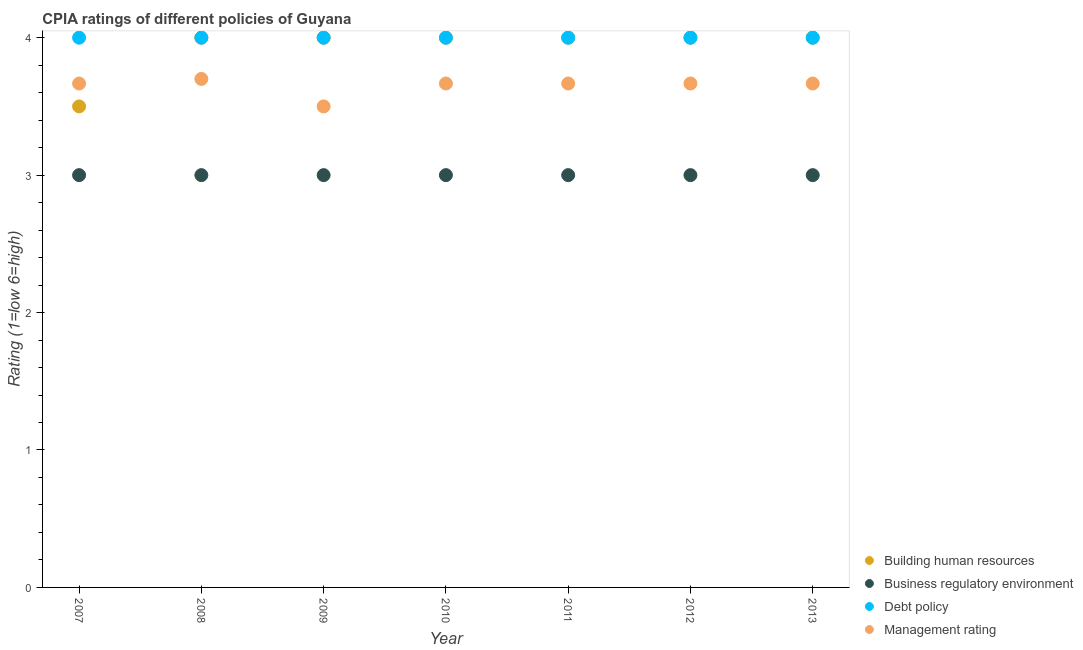How many different coloured dotlines are there?
Ensure brevity in your answer.  4. What is the cpia rating of business regulatory environment in 2009?
Ensure brevity in your answer.  3. Across all years, what is the minimum cpia rating of building human resources?
Keep it short and to the point. 3.5. In which year was the cpia rating of business regulatory environment maximum?
Your answer should be very brief. 2007. In which year was the cpia rating of management minimum?
Make the answer very short. 2009. What is the total cpia rating of management in the graph?
Your answer should be very brief. 25.53. What is the difference between the cpia rating of management in 2012 and the cpia rating of business regulatory environment in 2008?
Give a very brief answer. 0.67. What is the average cpia rating of management per year?
Provide a short and direct response. 3.65. In the year 2011, what is the difference between the cpia rating of building human resources and cpia rating of management?
Provide a succinct answer. 0.33. What is the ratio of the cpia rating of management in 2007 to that in 2008?
Keep it short and to the point. 0.99. Is the cpia rating of building human resources in 2008 less than that in 2012?
Offer a terse response. No. In how many years, is the cpia rating of building human resources greater than the average cpia rating of building human resources taken over all years?
Provide a succinct answer. 6. Is it the case that in every year, the sum of the cpia rating of management and cpia rating of business regulatory environment is greater than the sum of cpia rating of building human resources and cpia rating of debt policy?
Ensure brevity in your answer.  No. Does the cpia rating of management monotonically increase over the years?
Offer a terse response. No. Is the cpia rating of business regulatory environment strictly greater than the cpia rating of management over the years?
Ensure brevity in your answer.  No. How many dotlines are there?
Provide a short and direct response. 4. How many years are there in the graph?
Offer a terse response. 7. Does the graph contain any zero values?
Your answer should be very brief. No. Does the graph contain grids?
Your response must be concise. No. How are the legend labels stacked?
Your answer should be compact. Vertical. What is the title of the graph?
Offer a very short reply. CPIA ratings of different policies of Guyana. What is the label or title of the X-axis?
Give a very brief answer. Year. What is the Rating (1=low 6=high) in Debt policy in 2007?
Your response must be concise. 4. What is the Rating (1=low 6=high) of Management rating in 2007?
Your answer should be very brief. 3.67. What is the Rating (1=low 6=high) of Debt policy in 2008?
Provide a succinct answer. 4. What is the Rating (1=low 6=high) in Management rating in 2008?
Your answer should be compact. 3.7. What is the Rating (1=low 6=high) of Business regulatory environment in 2009?
Offer a very short reply. 3. What is the Rating (1=low 6=high) in Debt policy in 2009?
Provide a short and direct response. 4. What is the Rating (1=low 6=high) of Management rating in 2009?
Ensure brevity in your answer.  3.5. What is the Rating (1=low 6=high) in Business regulatory environment in 2010?
Make the answer very short. 3. What is the Rating (1=low 6=high) in Debt policy in 2010?
Give a very brief answer. 4. What is the Rating (1=low 6=high) of Management rating in 2010?
Provide a succinct answer. 3.67. What is the Rating (1=low 6=high) of Building human resources in 2011?
Offer a very short reply. 4. What is the Rating (1=low 6=high) in Business regulatory environment in 2011?
Offer a terse response. 3. What is the Rating (1=low 6=high) of Debt policy in 2011?
Ensure brevity in your answer.  4. What is the Rating (1=low 6=high) in Management rating in 2011?
Give a very brief answer. 3.67. What is the Rating (1=low 6=high) of Building human resources in 2012?
Offer a very short reply. 4. What is the Rating (1=low 6=high) of Business regulatory environment in 2012?
Offer a terse response. 3. What is the Rating (1=low 6=high) of Management rating in 2012?
Make the answer very short. 3.67. What is the Rating (1=low 6=high) in Building human resources in 2013?
Make the answer very short. 4. What is the Rating (1=low 6=high) of Management rating in 2013?
Your answer should be compact. 3.67. Across all years, what is the maximum Rating (1=low 6=high) of Building human resources?
Your answer should be compact. 4. Across all years, what is the maximum Rating (1=low 6=high) in Business regulatory environment?
Your answer should be compact. 3. Across all years, what is the maximum Rating (1=low 6=high) in Debt policy?
Make the answer very short. 4. Across all years, what is the minimum Rating (1=low 6=high) of Building human resources?
Ensure brevity in your answer.  3.5. What is the total Rating (1=low 6=high) in Business regulatory environment in the graph?
Provide a short and direct response. 21. What is the total Rating (1=low 6=high) in Debt policy in the graph?
Offer a very short reply. 28. What is the total Rating (1=low 6=high) in Management rating in the graph?
Give a very brief answer. 25.53. What is the difference between the Rating (1=low 6=high) in Business regulatory environment in 2007 and that in 2008?
Make the answer very short. 0. What is the difference between the Rating (1=low 6=high) in Debt policy in 2007 and that in 2008?
Your answer should be very brief. 0. What is the difference between the Rating (1=low 6=high) in Management rating in 2007 and that in 2008?
Your answer should be very brief. -0.03. What is the difference between the Rating (1=low 6=high) in Building human resources in 2007 and that in 2009?
Provide a short and direct response. -0.5. What is the difference between the Rating (1=low 6=high) in Building human resources in 2007 and that in 2010?
Provide a short and direct response. -0.5. What is the difference between the Rating (1=low 6=high) of Business regulatory environment in 2007 and that in 2010?
Provide a short and direct response. 0. What is the difference between the Rating (1=low 6=high) of Building human resources in 2007 and that in 2011?
Your answer should be compact. -0.5. What is the difference between the Rating (1=low 6=high) of Business regulatory environment in 2007 and that in 2011?
Ensure brevity in your answer.  0. What is the difference between the Rating (1=low 6=high) in Debt policy in 2007 and that in 2011?
Your response must be concise. 0. What is the difference between the Rating (1=low 6=high) of Debt policy in 2007 and that in 2012?
Your answer should be compact. 0. What is the difference between the Rating (1=low 6=high) in Building human resources in 2007 and that in 2013?
Provide a succinct answer. -0.5. What is the difference between the Rating (1=low 6=high) of Debt policy in 2007 and that in 2013?
Offer a terse response. 0. What is the difference between the Rating (1=low 6=high) in Management rating in 2007 and that in 2013?
Offer a terse response. 0. What is the difference between the Rating (1=low 6=high) of Building human resources in 2008 and that in 2009?
Give a very brief answer. 0. What is the difference between the Rating (1=low 6=high) of Business regulatory environment in 2008 and that in 2009?
Keep it short and to the point. 0. What is the difference between the Rating (1=low 6=high) in Management rating in 2008 and that in 2009?
Keep it short and to the point. 0.2. What is the difference between the Rating (1=low 6=high) of Business regulatory environment in 2008 and that in 2010?
Make the answer very short. 0. What is the difference between the Rating (1=low 6=high) of Building human resources in 2008 and that in 2011?
Provide a succinct answer. 0. What is the difference between the Rating (1=low 6=high) of Debt policy in 2008 and that in 2012?
Your response must be concise. 0. What is the difference between the Rating (1=low 6=high) in Management rating in 2008 and that in 2012?
Provide a succinct answer. 0.03. What is the difference between the Rating (1=low 6=high) of Debt policy in 2008 and that in 2013?
Give a very brief answer. 0. What is the difference between the Rating (1=low 6=high) of Management rating in 2008 and that in 2013?
Provide a short and direct response. 0.03. What is the difference between the Rating (1=low 6=high) of Building human resources in 2009 and that in 2010?
Provide a short and direct response. 0. What is the difference between the Rating (1=low 6=high) of Building human resources in 2009 and that in 2011?
Your answer should be very brief. 0. What is the difference between the Rating (1=low 6=high) in Debt policy in 2009 and that in 2011?
Your answer should be compact. 0. What is the difference between the Rating (1=low 6=high) of Management rating in 2009 and that in 2011?
Your answer should be very brief. -0.17. What is the difference between the Rating (1=low 6=high) of Building human resources in 2009 and that in 2012?
Make the answer very short. 0. What is the difference between the Rating (1=low 6=high) in Business regulatory environment in 2009 and that in 2012?
Provide a succinct answer. 0. What is the difference between the Rating (1=low 6=high) of Debt policy in 2009 and that in 2012?
Make the answer very short. 0. What is the difference between the Rating (1=low 6=high) of Debt policy in 2009 and that in 2013?
Provide a short and direct response. 0. What is the difference between the Rating (1=low 6=high) of Building human resources in 2010 and that in 2011?
Offer a very short reply. 0. What is the difference between the Rating (1=low 6=high) in Management rating in 2010 and that in 2011?
Offer a very short reply. 0. What is the difference between the Rating (1=low 6=high) in Building human resources in 2010 and that in 2012?
Offer a terse response. 0. What is the difference between the Rating (1=low 6=high) in Business regulatory environment in 2010 and that in 2012?
Your answer should be very brief. 0. What is the difference between the Rating (1=low 6=high) in Debt policy in 2010 and that in 2012?
Give a very brief answer. 0. What is the difference between the Rating (1=low 6=high) of Management rating in 2010 and that in 2012?
Give a very brief answer. 0. What is the difference between the Rating (1=low 6=high) in Business regulatory environment in 2011 and that in 2013?
Your answer should be very brief. 0. What is the difference between the Rating (1=low 6=high) in Debt policy in 2011 and that in 2013?
Make the answer very short. 0. What is the difference between the Rating (1=low 6=high) in Management rating in 2011 and that in 2013?
Offer a very short reply. 0. What is the difference between the Rating (1=low 6=high) of Business regulatory environment in 2012 and that in 2013?
Offer a very short reply. 0. What is the difference between the Rating (1=low 6=high) of Debt policy in 2012 and that in 2013?
Give a very brief answer. 0. What is the difference between the Rating (1=low 6=high) of Management rating in 2012 and that in 2013?
Give a very brief answer. 0. What is the difference between the Rating (1=low 6=high) in Building human resources in 2007 and the Rating (1=low 6=high) in Debt policy in 2008?
Offer a very short reply. -0.5. What is the difference between the Rating (1=low 6=high) in Business regulatory environment in 2007 and the Rating (1=low 6=high) in Debt policy in 2008?
Provide a short and direct response. -1. What is the difference between the Rating (1=low 6=high) in Debt policy in 2007 and the Rating (1=low 6=high) in Management rating in 2008?
Offer a very short reply. 0.3. What is the difference between the Rating (1=low 6=high) of Building human resources in 2007 and the Rating (1=low 6=high) of Debt policy in 2009?
Your answer should be compact. -0.5. What is the difference between the Rating (1=low 6=high) in Business regulatory environment in 2007 and the Rating (1=low 6=high) in Management rating in 2009?
Your answer should be compact. -0.5. What is the difference between the Rating (1=low 6=high) in Building human resources in 2007 and the Rating (1=low 6=high) in Business regulatory environment in 2010?
Keep it short and to the point. 0.5. What is the difference between the Rating (1=low 6=high) of Business regulatory environment in 2007 and the Rating (1=low 6=high) of Debt policy in 2010?
Provide a succinct answer. -1. What is the difference between the Rating (1=low 6=high) of Debt policy in 2007 and the Rating (1=low 6=high) of Management rating in 2010?
Provide a succinct answer. 0.33. What is the difference between the Rating (1=low 6=high) of Building human resources in 2007 and the Rating (1=low 6=high) of Debt policy in 2011?
Offer a very short reply. -0.5. What is the difference between the Rating (1=low 6=high) in Building human resources in 2007 and the Rating (1=low 6=high) in Management rating in 2011?
Offer a terse response. -0.17. What is the difference between the Rating (1=low 6=high) of Business regulatory environment in 2007 and the Rating (1=low 6=high) of Debt policy in 2011?
Ensure brevity in your answer.  -1. What is the difference between the Rating (1=low 6=high) in Debt policy in 2007 and the Rating (1=low 6=high) in Management rating in 2011?
Your response must be concise. 0.33. What is the difference between the Rating (1=low 6=high) in Building human resources in 2007 and the Rating (1=low 6=high) in Business regulatory environment in 2012?
Provide a short and direct response. 0.5. What is the difference between the Rating (1=low 6=high) in Business regulatory environment in 2007 and the Rating (1=low 6=high) in Debt policy in 2012?
Offer a terse response. -1. What is the difference between the Rating (1=low 6=high) in Debt policy in 2007 and the Rating (1=low 6=high) in Management rating in 2012?
Provide a short and direct response. 0.33. What is the difference between the Rating (1=low 6=high) in Building human resources in 2007 and the Rating (1=low 6=high) in Debt policy in 2013?
Make the answer very short. -0.5. What is the difference between the Rating (1=low 6=high) of Building human resources in 2007 and the Rating (1=low 6=high) of Management rating in 2013?
Make the answer very short. -0.17. What is the difference between the Rating (1=low 6=high) in Business regulatory environment in 2007 and the Rating (1=low 6=high) in Debt policy in 2013?
Keep it short and to the point. -1. What is the difference between the Rating (1=low 6=high) in Debt policy in 2007 and the Rating (1=low 6=high) in Management rating in 2013?
Give a very brief answer. 0.33. What is the difference between the Rating (1=low 6=high) in Building human resources in 2008 and the Rating (1=low 6=high) in Debt policy in 2009?
Keep it short and to the point. 0. What is the difference between the Rating (1=low 6=high) of Business regulatory environment in 2008 and the Rating (1=low 6=high) of Debt policy in 2009?
Offer a terse response. -1. What is the difference between the Rating (1=low 6=high) of Business regulatory environment in 2008 and the Rating (1=low 6=high) of Management rating in 2009?
Give a very brief answer. -0.5. What is the difference between the Rating (1=low 6=high) in Debt policy in 2008 and the Rating (1=low 6=high) in Management rating in 2009?
Keep it short and to the point. 0.5. What is the difference between the Rating (1=low 6=high) in Business regulatory environment in 2008 and the Rating (1=low 6=high) in Management rating in 2010?
Ensure brevity in your answer.  -0.67. What is the difference between the Rating (1=low 6=high) of Building human resources in 2008 and the Rating (1=low 6=high) of Debt policy in 2011?
Provide a short and direct response. 0. What is the difference between the Rating (1=low 6=high) of Building human resources in 2008 and the Rating (1=low 6=high) of Management rating in 2011?
Keep it short and to the point. 0.33. What is the difference between the Rating (1=low 6=high) of Business regulatory environment in 2008 and the Rating (1=low 6=high) of Debt policy in 2011?
Give a very brief answer. -1. What is the difference between the Rating (1=low 6=high) in Debt policy in 2008 and the Rating (1=low 6=high) in Management rating in 2011?
Provide a short and direct response. 0.33. What is the difference between the Rating (1=low 6=high) of Building human resources in 2008 and the Rating (1=low 6=high) of Business regulatory environment in 2012?
Provide a short and direct response. 1. What is the difference between the Rating (1=low 6=high) of Building human resources in 2008 and the Rating (1=low 6=high) of Debt policy in 2012?
Your answer should be compact. 0. What is the difference between the Rating (1=low 6=high) of Business regulatory environment in 2008 and the Rating (1=low 6=high) of Debt policy in 2012?
Keep it short and to the point. -1. What is the difference between the Rating (1=low 6=high) of Building human resources in 2008 and the Rating (1=low 6=high) of Business regulatory environment in 2013?
Provide a succinct answer. 1. What is the difference between the Rating (1=low 6=high) of Building human resources in 2009 and the Rating (1=low 6=high) of Management rating in 2010?
Your response must be concise. 0.33. What is the difference between the Rating (1=low 6=high) of Debt policy in 2009 and the Rating (1=low 6=high) of Management rating in 2010?
Provide a succinct answer. 0.33. What is the difference between the Rating (1=low 6=high) of Building human resources in 2009 and the Rating (1=low 6=high) of Business regulatory environment in 2011?
Your response must be concise. 1. What is the difference between the Rating (1=low 6=high) in Business regulatory environment in 2009 and the Rating (1=low 6=high) in Debt policy in 2011?
Keep it short and to the point. -1. What is the difference between the Rating (1=low 6=high) in Building human resources in 2009 and the Rating (1=low 6=high) in Debt policy in 2012?
Give a very brief answer. 0. What is the difference between the Rating (1=low 6=high) in Business regulatory environment in 2009 and the Rating (1=low 6=high) in Debt policy in 2012?
Ensure brevity in your answer.  -1. What is the difference between the Rating (1=low 6=high) of Business regulatory environment in 2009 and the Rating (1=low 6=high) of Management rating in 2012?
Your answer should be compact. -0.67. What is the difference between the Rating (1=low 6=high) in Debt policy in 2009 and the Rating (1=low 6=high) in Management rating in 2012?
Make the answer very short. 0.33. What is the difference between the Rating (1=low 6=high) in Building human resources in 2009 and the Rating (1=low 6=high) in Business regulatory environment in 2013?
Your answer should be very brief. 1. What is the difference between the Rating (1=low 6=high) of Building human resources in 2009 and the Rating (1=low 6=high) of Management rating in 2013?
Provide a short and direct response. 0.33. What is the difference between the Rating (1=low 6=high) in Business regulatory environment in 2009 and the Rating (1=low 6=high) in Debt policy in 2013?
Offer a terse response. -1. What is the difference between the Rating (1=low 6=high) in Business regulatory environment in 2009 and the Rating (1=low 6=high) in Management rating in 2013?
Give a very brief answer. -0.67. What is the difference between the Rating (1=low 6=high) of Business regulatory environment in 2010 and the Rating (1=low 6=high) of Debt policy in 2011?
Ensure brevity in your answer.  -1. What is the difference between the Rating (1=low 6=high) of Business regulatory environment in 2010 and the Rating (1=low 6=high) of Management rating in 2011?
Give a very brief answer. -0.67. What is the difference between the Rating (1=low 6=high) in Business regulatory environment in 2010 and the Rating (1=low 6=high) in Debt policy in 2012?
Keep it short and to the point. -1. What is the difference between the Rating (1=low 6=high) of Debt policy in 2010 and the Rating (1=low 6=high) of Management rating in 2012?
Offer a very short reply. 0.33. What is the difference between the Rating (1=low 6=high) in Building human resources in 2010 and the Rating (1=low 6=high) in Debt policy in 2013?
Offer a very short reply. 0. What is the difference between the Rating (1=low 6=high) of Building human resources in 2010 and the Rating (1=low 6=high) of Management rating in 2013?
Give a very brief answer. 0.33. What is the difference between the Rating (1=low 6=high) in Business regulatory environment in 2010 and the Rating (1=low 6=high) in Debt policy in 2013?
Offer a terse response. -1. What is the difference between the Rating (1=low 6=high) in Building human resources in 2011 and the Rating (1=low 6=high) in Business regulatory environment in 2012?
Your response must be concise. 1. What is the difference between the Rating (1=low 6=high) in Building human resources in 2011 and the Rating (1=low 6=high) in Debt policy in 2012?
Your answer should be compact. 0. What is the difference between the Rating (1=low 6=high) of Building human resources in 2011 and the Rating (1=low 6=high) of Management rating in 2012?
Offer a very short reply. 0.33. What is the difference between the Rating (1=low 6=high) of Business regulatory environment in 2011 and the Rating (1=low 6=high) of Debt policy in 2012?
Your response must be concise. -1. What is the difference between the Rating (1=low 6=high) of Business regulatory environment in 2011 and the Rating (1=low 6=high) of Management rating in 2012?
Make the answer very short. -0.67. What is the difference between the Rating (1=low 6=high) of Debt policy in 2011 and the Rating (1=low 6=high) of Management rating in 2012?
Your response must be concise. 0.33. What is the difference between the Rating (1=low 6=high) in Building human resources in 2011 and the Rating (1=low 6=high) in Management rating in 2013?
Provide a succinct answer. 0.33. What is the difference between the Rating (1=low 6=high) of Business regulatory environment in 2011 and the Rating (1=low 6=high) of Debt policy in 2013?
Keep it short and to the point. -1. What is the difference between the Rating (1=low 6=high) in Business regulatory environment in 2011 and the Rating (1=low 6=high) in Management rating in 2013?
Your answer should be compact. -0.67. What is the difference between the Rating (1=low 6=high) in Building human resources in 2012 and the Rating (1=low 6=high) in Debt policy in 2013?
Make the answer very short. 0. What is the difference between the Rating (1=low 6=high) in Building human resources in 2012 and the Rating (1=low 6=high) in Management rating in 2013?
Give a very brief answer. 0.33. What is the difference between the Rating (1=low 6=high) of Business regulatory environment in 2012 and the Rating (1=low 6=high) of Debt policy in 2013?
Offer a very short reply. -1. What is the difference between the Rating (1=low 6=high) of Business regulatory environment in 2012 and the Rating (1=low 6=high) of Management rating in 2013?
Offer a very short reply. -0.67. What is the difference between the Rating (1=low 6=high) of Debt policy in 2012 and the Rating (1=low 6=high) of Management rating in 2013?
Provide a succinct answer. 0.33. What is the average Rating (1=low 6=high) in Building human resources per year?
Give a very brief answer. 3.93. What is the average Rating (1=low 6=high) in Management rating per year?
Your response must be concise. 3.65. In the year 2007, what is the difference between the Rating (1=low 6=high) of Building human resources and Rating (1=low 6=high) of Business regulatory environment?
Ensure brevity in your answer.  0.5. In the year 2007, what is the difference between the Rating (1=low 6=high) in Business regulatory environment and Rating (1=low 6=high) in Management rating?
Your answer should be compact. -0.67. In the year 2009, what is the difference between the Rating (1=low 6=high) in Building human resources and Rating (1=low 6=high) in Management rating?
Your answer should be compact. 0.5. In the year 2009, what is the difference between the Rating (1=low 6=high) in Business regulatory environment and Rating (1=low 6=high) in Debt policy?
Your answer should be compact. -1. In the year 2009, what is the difference between the Rating (1=low 6=high) of Debt policy and Rating (1=low 6=high) of Management rating?
Keep it short and to the point. 0.5. In the year 2010, what is the difference between the Rating (1=low 6=high) of Building human resources and Rating (1=low 6=high) of Business regulatory environment?
Your answer should be very brief. 1. In the year 2010, what is the difference between the Rating (1=low 6=high) in Building human resources and Rating (1=low 6=high) in Debt policy?
Keep it short and to the point. 0. In the year 2010, what is the difference between the Rating (1=low 6=high) of Building human resources and Rating (1=low 6=high) of Management rating?
Your response must be concise. 0.33. In the year 2010, what is the difference between the Rating (1=low 6=high) of Business regulatory environment and Rating (1=low 6=high) of Debt policy?
Provide a short and direct response. -1. In the year 2010, what is the difference between the Rating (1=low 6=high) of Business regulatory environment and Rating (1=low 6=high) of Management rating?
Offer a very short reply. -0.67. In the year 2010, what is the difference between the Rating (1=low 6=high) in Debt policy and Rating (1=low 6=high) in Management rating?
Give a very brief answer. 0.33. In the year 2011, what is the difference between the Rating (1=low 6=high) in Building human resources and Rating (1=low 6=high) in Management rating?
Keep it short and to the point. 0.33. In the year 2011, what is the difference between the Rating (1=low 6=high) in Debt policy and Rating (1=low 6=high) in Management rating?
Give a very brief answer. 0.33. In the year 2012, what is the difference between the Rating (1=low 6=high) in Building human resources and Rating (1=low 6=high) in Business regulatory environment?
Offer a very short reply. 1. In the year 2012, what is the difference between the Rating (1=low 6=high) of Building human resources and Rating (1=low 6=high) of Management rating?
Ensure brevity in your answer.  0.33. In the year 2012, what is the difference between the Rating (1=low 6=high) of Debt policy and Rating (1=low 6=high) of Management rating?
Provide a succinct answer. 0.33. In the year 2013, what is the difference between the Rating (1=low 6=high) in Building human resources and Rating (1=low 6=high) in Debt policy?
Offer a terse response. 0. In the year 2013, what is the difference between the Rating (1=low 6=high) in Building human resources and Rating (1=low 6=high) in Management rating?
Your response must be concise. 0.33. What is the ratio of the Rating (1=low 6=high) in Building human resources in 2007 to that in 2008?
Offer a terse response. 0.88. What is the ratio of the Rating (1=low 6=high) of Business regulatory environment in 2007 to that in 2008?
Your answer should be compact. 1. What is the ratio of the Rating (1=low 6=high) in Debt policy in 2007 to that in 2008?
Your response must be concise. 1. What is the ratio of the Rating (1=low 6=high) of Building human resources in 2007 to that in 2009?
Keep it short and to the point. 0.88. What is the ratio of the Rating (1=low 6=high) of Debt policy in 2007 to that in 2009?
Your response must be concise. 1. What is the ratio of the Rating (1=low 6=high) in Management rating in 2007 to that in 2009?
Provide a succinct answer. 1.05. What is the ratio of the Rating (1=low 6=high) in Business regulatory environment in 2007 to that in 2010?
Keep it short and to the point. 1. What is the ratio of the Rating (1=low 6=high) of Management rating in 2007 to that in 2010?
Offer a terse response. 1. What is the ratio of the Rating (1=low 6=high) in Building human resources in 2007 to that in 2011?
Ensure brevity in your answer.  0.88. What is the ratio of the Rating (1=low 6=high) in Business regulatory environment in 2007 to that in 2011?
Your answer should be very brief. 1. What is the ratio of the Rating (1=low 6=high) in Building human resources in 2007 to that in 2012?
Keep it short and to the point. 0.88. What is the ratio of the Rating (1=low 6=high) in Business regulatory environment in 2007 to that in 2012?
Provide a succinct answer. 1. What is the ratio of the Rating (1=low 6=high) in Building human resources in 2007 to that in 2013?
Offer a very short reply. 0.88. What is the ratio of the Rating (1=low 6=high) in Business regulatory environment in 2007 to that in 2013?
Your response must be concise. 1. What is the ratio of the Rating (1=low 6=high) of Management rating in 2007 to that in 2013?
Your answer should be very brief. 1. What is the ratio of the Rating (1=low 6=high) of Building human resources in 2008 to that in 2009?
Your response must be concise. 1. What is the ratio of the Rating (1=low 6=high) in Debt policy in 2008 to that in 2009?
Offer a terse response. 1. What is the ratio of the Rating (1=low 6=high) in Management rating in 2008 to that in 2009?
Your response must be concise. 1.06. What is the ratio of the Rating (1=low 6=high) of Building human resources in 2008 to that in 2010?
Your answer should be very brief. 1. What is the ratio of the Rating (1=low 6=high) of Business regulatory environment in 2008 to that in 2010?
Keep it short and to the point. 1. What is the ratio of the Rating (1=low 6=high) of Management rating in 2008 to that in 2010?
Make the answer very short. 1.01. What is the ratio of the Rating (1=low 6=high) of Building human resources in 2008 to that in 2011?
Your answer should be very brief. 1. What is the ratio of the Rating (1=low 6=high) of Business regulatory environment in 2008 to that in 2011?
Your answer should be very brief. 1. What is the ratio of the Rating (1=low 6=high) of Debt policy in 2008 to that in 2011?
Your answer should be very brief. 1. What is the ratio of the Rating (1=low 6=high) of Management rating in 2008 to that in 2011?
Your response must be concise. 1.01. What is the ratio of the Rating (1=low 6=high) in Building human resources in 2008 to that in 2012?
Your response must be concise. 1. What is the ratio of the Rating (1=low 6=high) in Business regulatory environment in 2008 to that in 2012?
Ensure brevity in your answer.  1. What is the ratio of the Rating (1=low 6=high) in Debt policy in 2008 to that in 2012?
Ensure brevity in your answer.  1. What is the ratio of the Rating (1=low 6=high) of Management rating in 2008 to that in 2012?
Your answer should be compact. 1.01. What is the ratio of the Rating (1=low 6=high) of Debt policy in 2008 to that in 2013?
Your answer should be very brief. 1. What is the ratio of the Rating (1=low 6=high) of Management rating in 2008 to that in 2013?
Give a very brief answer. 1.01. What is the ratio of the Rating (1=low 6=high) in Debt policy in 2009 to that in 2010?
Provide a short and direct response. 1. What is the ratio of the Rating (1=low 6=high) of Management rating in 2009 to that in 2010?
Your answer should be compact. 0.95. What is the ratio of the Rating (1=low 6=high) in Management rating in 2009 to that in 2011?
Ensure brevity in your answer.  0.95. What is the ratio of the Rating (1=low 6=high) in Building human resources in 2009 to that in 2012?
Your answer should be compact. 1. What is the ratio of the Rating (1=low 6=high) of Business regulatory environment in 2009 to that in 2012?
Provide a succinct answer. 1. What is the ratio of the Rating (1=low 6=high) in Management rating in 2009 to that in 2012?
Make the answer very short. 0.95. What is the ratio of the Rating (1=low 6=high) of Building human resources in 2009 to that in 2013?
Provide a succinct answer. 1. What is the ratio of the Rating (1=low 6=high) of Management rating in 2009 to that in 2013?
Make the answer very short. 0.95. What is the ratio of the Rating (1=low 6=high) in Building human resources in 2010 to that in 2011?
Provide a succinct answer. 1. What is the ratio of the Rating (1=low 6=high) in Business regulatory environment in 2010 to that in 2011?
Your response must be concise. 1. What is the ratio of the Rating (1=low 6=high) in Building human resources in 2010 to that in 2012?
Give a very brief answer. 1. What is the ratio of the Rating (1=low 6=high) of Business regulatory environment in 2010 to that in 2012?
Offer a terse response. 1. What is the ratio of the Rating (1=low 6=high) of Debt policy in 2010 to that in 2012?
Your answer should be compact. 1. What is the ratio of the Rating (1=low 6=high) in Management rating in 2010 to that in 2012?
Make the answer very short. 1. What is the ratio of the Rating (1=low 6=high) of Business regulatory environment in 2010 to that in 2013?
Keep it short and to the point. 1. What is the ratio of the Rating (1=low 6=high) in Debt policy in 2010 to that in 2013?
Your response must be concise. 1. What is the ratio of the Rating (1=low 6=high) in Management rating in 2010 to that in 2013?
Make the answer very short. 1. What is the ratio of the Rating (1=low 6=high) in Building human resources in 2011 to that in 2012?
Your answer should be compact. 1. What is the ratio of the Rating (1=low 6=high) in Business regulatory environment in 2011 to that in 2012?
Offer a terse response. 1. What is the ratio of the Rating (1=low 6=high) of Debt policy in 2011 to that in 2012?
Make the answer very short. 1. What is the ratio of the Rating (1=low 6=high) of Business regulatory environment in 2011 to that in 2013?
Offer a very short reply. 1. What is the ratio of the Rating (1=low 6=high) in Debt policy in 2011 to that in 2013?
Provide a succinct answer. 1. What is the ratio of the Rating (1=low 6=high) of Management rating in 2011 to that in 2013?
Offer a very short reply. 1. What is the ratio of the Rating (1=low 6=high) of Building human resources in 2012 to that in 2013?
Make the answer very short. 1. What is the ratio of the Rating (1=low 6=high) in Management rating in 2012 to that in 2013?
Your answer should be compact. 1. What is the difference between the highest and the second highest Rating (1=low 6=high) of Management rating?
Give a very brief answer. 0.03. What is the difference between the highest and the lowest Rating (1=low 6=high) in Debt policy?
Your answer should be very brief. 0. 